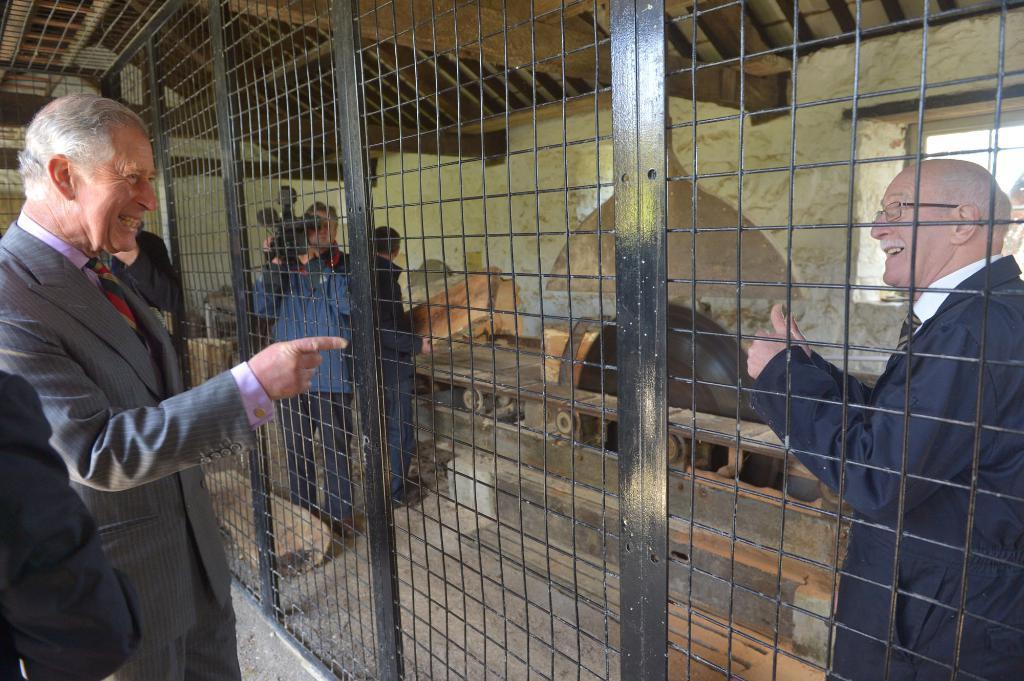Can you describe this image briefly? This image consists of many people. To the left, the man standing is wearing a suit. In the middle, the man wearing blue jacket is holding a camera. In the middle, there is a grill. At the top, there is a roof. 